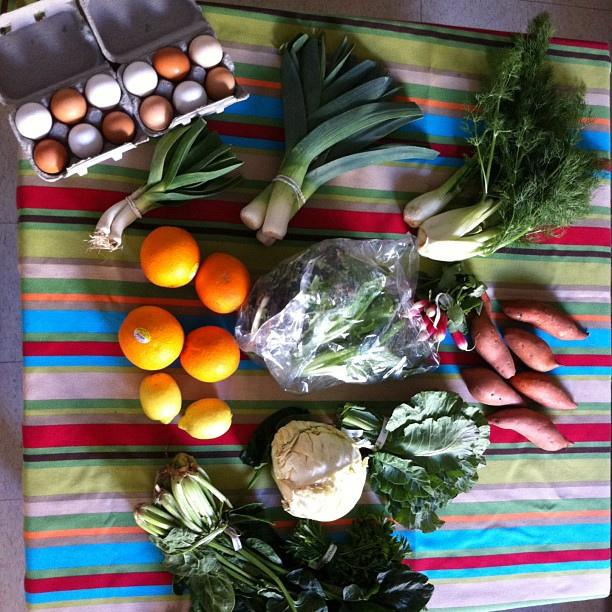What are the objects placed on?

Choices:
A) floor
B) sofa
C) towel
D) paper towel 